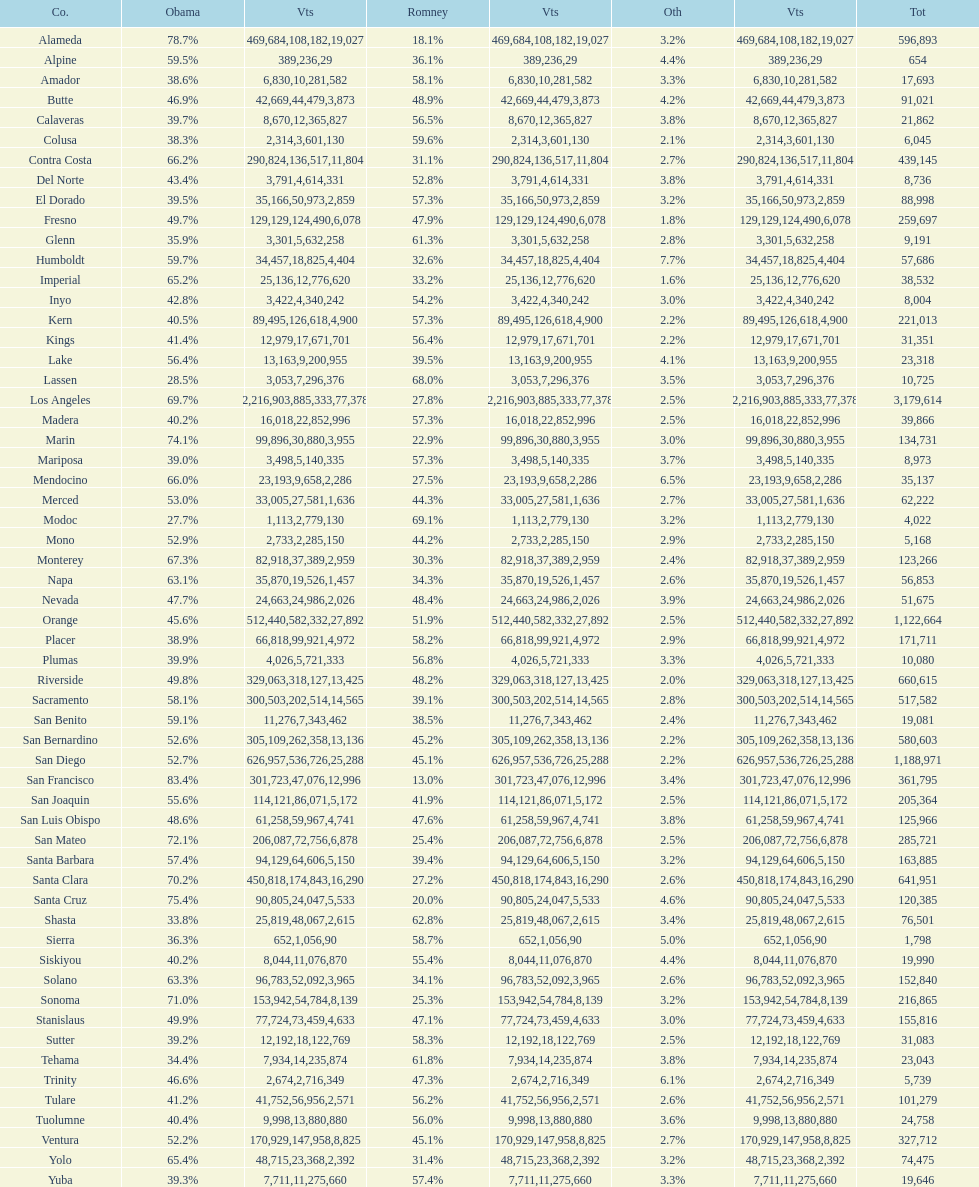How many counties had at least 75% of the votes for obama? 3. 